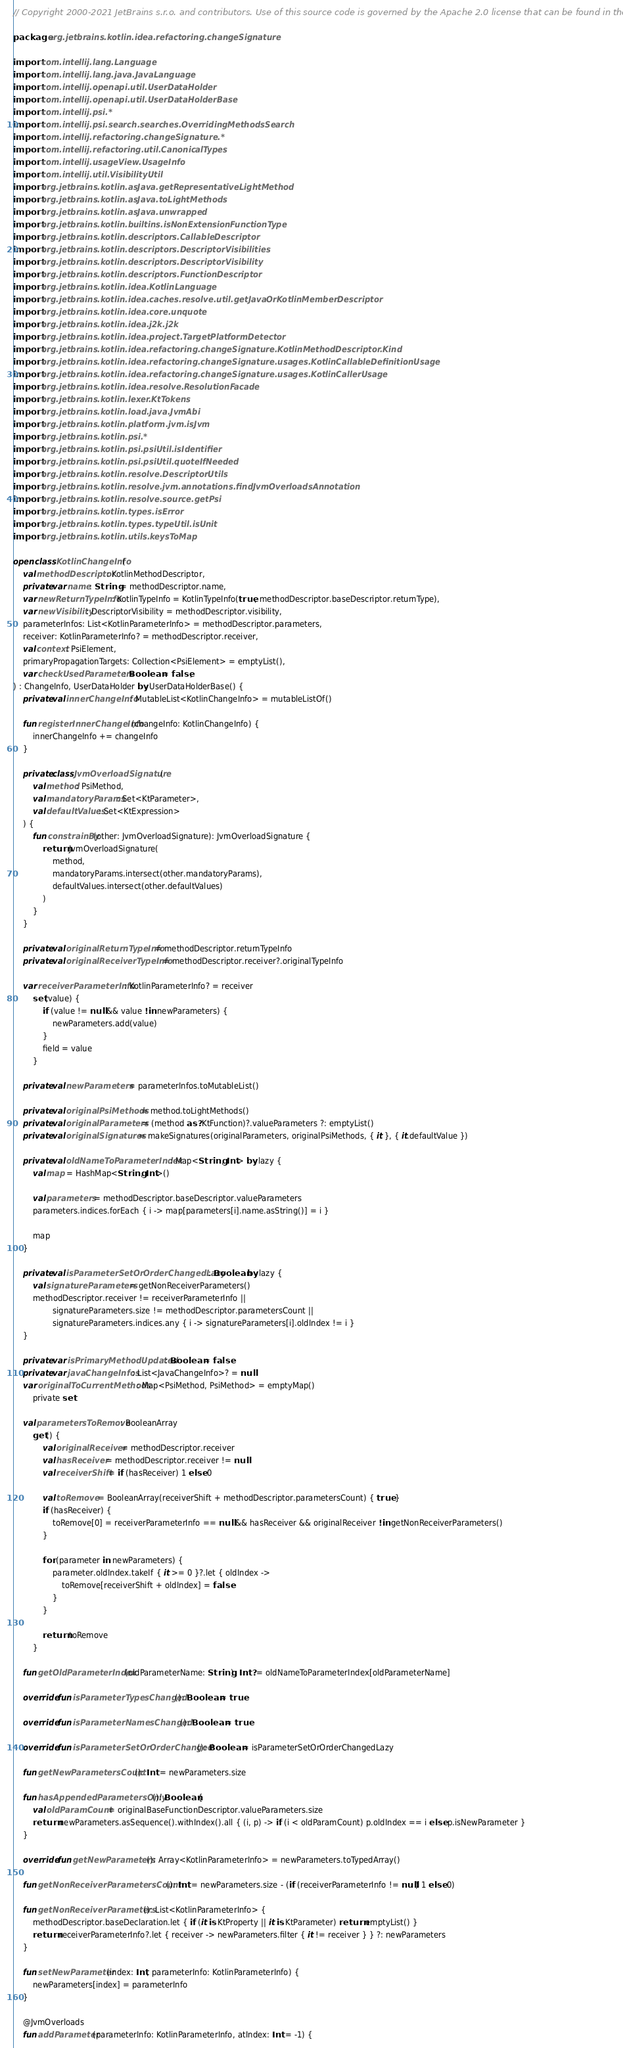<code> <loc_0><loc_0><loc_500><loc_500><_Kotlin_>// Copyright 2000-2021 JetBrains s.r.o. and contributors. Use of this source code is governed by the Apache 2.0 license that can be found in the LICENSE file.

package org.jetbrains.kotlin.idea.refactoring.changeSignature

import com.intellij.lang.Language
import com.intellij.lang.java.JavaLanguage
import com.intellij.openapi.util.UserDataHolder
import com.intellij.openapi.util.UserDataHolderBase
import com.intellij.psi.*
import com.intellij.psi.search.searches.OverridingMethodsSearch
import com.intellij.refactoring.changeSignature.*
import com.intellij.refactoring.util.CanonicalTypes
import com.intellij.usageView.UsageInfo
import com.intellij.util.VisibilityUtil
import org.jetbrains.kotlin.asJava.getRepresentativeLightMethod
import org.jetbrains.kotlin.asJava.toLightMethods
import org.jetbrains.kotlin.asJava.unwrapped
import org.jetbrains.kotlin.builtins.isNonExtensionFunctionType
import org.jetbrains.kotlin.descriptors.CallableDescriptor
import org.jetbrains.kotlin.descriptors.DescriptorVisibilities
import org.jetbrains.kotlin.descriptors.DescriptorVisibility
import org.jetbrains.kotlin.descriptors.FunctionDescriptor
import org.jetbrains.kotlin.idea.KotlinLanguage
import org.jetbrains.kotlin.idea.caches.resolve.util.getJavaOrKotlinMemberDescriptor
import org.jetbrains.kotlin.idea.core.unquote
import org.jetbrains.kotlin.idea.j2k.j2k
import org.jetbrains.kotlin.idea.project.TargetPlatformDetector
import org.jetbrains.kotlin.idea.refactoring.changeSignature.KotlinMethodDescriptor.Kind
import org.jetbrains.kotlin.idea.refactoring.changeSignature.usages.KotlinCallableDefinitionUsage
import org.jetbrains.kotlin.idea.refactoring.changeSignature.usages.KotlinCallerUsage
import org.jetbrains.kotlin.idea.resolve.ResolutionFacade
import org.jetbrains.kotlin.lexer.KtTokens
import org.jetbrains.kotlin.load.java.JvmAbi
import org.jetbrains.kotlin.platform.jvm.isJvm
import org.jetbrains.kotlin.psi.*
import org.jetbrains.kotlin.psi.psiUtil.isIdentifier
import org.jetbrains.kotlin.psi.psiUtil.quoteIfNeeded
import org.jetbrains.kotlin.resolve.DescriptorUtils
import org.jetbrains.kotlin.resolve.jvm.annotations.findJvmOverloadsAnnotation
import org.jetbrains.kotlin.resolve.source.getPsi
import org.jetbrains.kotlin.types.isError
import org.jetbrains.kotlin.types.typeUtil.isUnit
import org.jetbrains.kotlin.utils.keysToMap

open class KotlinChangeInfo(
    val methodDescriptor: KotlinMethodDescriptor,
    private var name: String = methodDescriptor.name,
    var newReturnTypeInfo: KotlinTypeInfo = KotlinTypeInfo(true, methodDescriptor.baseDescriptor.returnType),
    var newVisibility: DescriptorVisibility = methodDescriptor.visibility,
    parameterInfos: List<KotlinParameterInfo> = methodDescriptor.parameters,
    receiver: KotlinParameterInfo? = methodDescriptor.receiver,
    val context: PsiElement,
    primaryPropagationTargets: Collection<PsiElement> = emptyList(),
    var checkUsedParameters: Boolean = false,
) : ChangeInfo, UserDataHolder by UserDataHolderBase() {
    private val innerChangeInfo: MutableList<KotlinChangeInfo> = mutableListOf()

    fun registerInnerChangeInfo(changeInfo: KotlinChangeInfo) {
        innerChangeInfo += changeInfo
    }

    private class JvmOverloadSignature(
        val method: PsiMethod,
        val mandatoryParams: Set<KtParameter>,
        val defaultValues: Set<KtExpression>
    ) {
        fun constrainBy(other: JvmOverloadSignature): JvmOverloadSignature {
            return JvmOverloadSignature(
                method,
                mandatoryParams.intersect(other.mandatoryParams),
                defaultValues.intersect(other.defaultValues)
            )
        }
    }

    private val originalReturnTypeInfo = methodDescriptor.returnTypeInfo
    private val originalReceiverTypeInfo = methodDescriptor.receiver?.originalTypeInfo

    var receiverParameterInfo: KotlinParameterInfo? = receiver
        set(value) {
            if (value != null && value !in newParameters) {
                newParameters.add(value)
            }
            field = value
        }

    private val newParameters = parameterInfos.toMutableList()

    private val originalPsiMethods = method.toLightMethods()
    private val originalParameters = (method as? KtFunction)?.valueParameters ?: emptyList()
    private val originalSignatures = makeSignatures(originalParameters, originalPsiMethods, { it }, { it.defaultValue })

    private val oldNameToParameterIndex: Map<String, Int> by lazy {
        val map = HashMap<String, Int>()

        val parameters = methodDescriptor.baseDescriptor.valueParameters
        parameters.indices.forEach { i -> map[parameters[i].name.asString()] = i }

        map
    }

    private val isParameterSetOrOrderChangedLazy: Boolean by lazy {
        val signatureParameters = getNonReceiverParameters()
        methodDescriptor.receiver != receiverParameterInfo ||
                signatureParameters.size != methodDescriptor.parametersCount ||
                signatureParameters.indices.any { i -> signatureParameters[i].oldIndex != i }
    }

    private var isPrimaryMethodUpdated: Boolean = false
    private var javaChangeInfos: List<JavaChangeInfo>? = null
    var originalToCurrentMethods: Map<PsiMethod, PsiMethod> = emptyMap()
        private set

    val parametersToRemove: BooleanArray
        get() {
            val originalReceiver = methodDescriptor.receiver
            val hasReceiver = methodDescriptor.receiver != null
            val receiverShift = if (hasReceiver) 1 else 0

            val toRemove = BooleanArray(receiverShift + methodDescriptor.parametersCount) { true }
            if (hasReceiver) {
                toRemove[0] = receiverParameterInfo == null && hasReceiver && originalReceiver !in getNonReceiverParameters()
            }

            for (parameter in newParameters) {
                parameter.oldIndex.takeIf { it >= 0 }?.let { oldIndex ->
                    toRemove[receiverShift + oldIndex] = false
                }
            }

            return toRemove
        }

    fun getOldParameterIndex(oldParameterName: String): Int? = oldNameToParameterIndex[oldParameterName]

    override fun isParameterTypesChanged(): Boolean = true

    override fun isParameterNamesChanged(): Boolean = true

    override fun isParameterSetOrOrderChanged(): Boolean = isParameterSetOrOrderChangedLazy

    fun getNewParametersCount(): Int = newParameters.size

    fun hasAppendedParametersOnly(): Boolean {
        val oldParamCount = originalBaseFunctionDescriptor.valueParameters.size
        return newParameters.asSequence().withIndex().all { (i, p) -> if (i < oldParamCount) p.oldIndex == i else p.isNewParameter }
    }

    override fun getNewParameters(): Array<KotlinParameterInfo> = newParameters.toTypedArray()

    fun getNonReceiverParametersCount(): Int = newParameters.size - (if (receiverParameterInfo != null) 1 else 0)

    fun getNonReceiverParameters(): List<KotlinParameterInfo> {
        methodDescriptor.baseDeclaration.let { if (it is KtProperty || it is KtParameter) return emptyList() }
        return receiverParameterInfo?.let { receiver -> newParameters.filter { it != receiver } } ?: newParameters
    }

    fun setNewParameter(index: Int, parameterInfo: KotlinParameterInfo) {
        newParameters[index] = parameterInfo
    }

    @JvmOverloads
    fun addParameter(parameterInfo: KotlinParameterInfo, atIndex: Int = -1) {</code> 